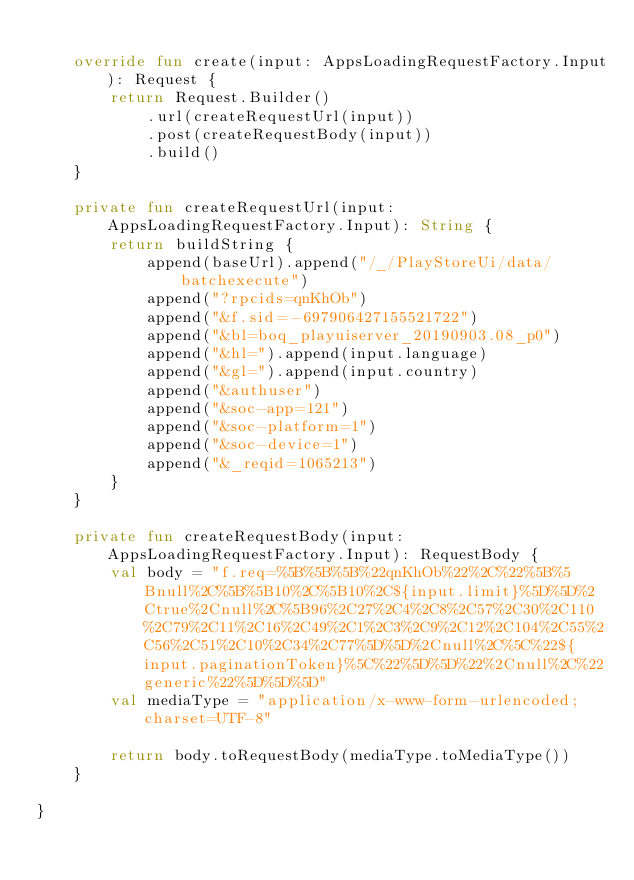Convert code to text. <code><loc_0><loc_0><loc_500><loc_500><_Kotlin_>
    override fun create(input: AppsLoadingRequestFactory.Input): Request {
        return Request.Builder()
            .url(createRequestUrl(input))
            .post(createRequestBody(input))
            .build()
    }

    private fun createRequestUrl(input: AppsLoadingRequestFactory.Input): String {
        return buildString {
            append(baseUrl).append("/_/PlayStoreUi/data/batchexecute")
            append("?rpcids=qnKhOb")
            append("&f.sid=-697906427155521722")
            append("&bl=boq_playuiserver_20190903.08_p0")
            append("&hl=").append(input.language)
            append("&gl=").append(input.country)
            append("&authuser")
            append("&soc-app=121")
            append("&soc-platform=1")
            append("&soc-device=1")
            append("&_reqid=1065213")
        }
    }

    private fun createRequestBody(input: AppsLoadingRequestFactory.Input): RequestBody {
        val body = "f.req=%5B%5B%5B%22qnKhOb%22%2C%22%5B%5Bnull%2C%5B%5B10%2C%5B10%2C${input.limit}%5D%5D%2Ctrue%2Cnull%2C%5B96%2C27%2C4%2C8%2C57%2C30%2C110%2C79%2C11%2C16%2C49%2C1%2C3%2C9%2C12%2C104%2C55%2C56%2C51%2C10%2C34%2C77%5D%5D%2Cnull%2C%5C%22${input.paginationToken}%5C%22%5D%5D%22%2Cnull%2C%22generic%22%5D%5D%5D"
        val mediaType = "application/x-www-form-urlencoded;charset=UTF-8"

        return body.toRequestBody(mediaType.toMediaType())
    }

}</code> 